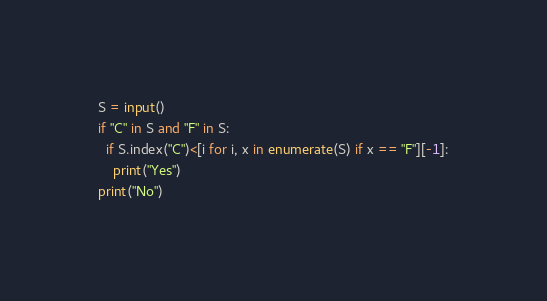<code> <loc_0><loc_0><loc_500><loc_500><_Python_>S = input()
if "C" in S and "F" in S:
  if S.index("C")<[i for i, x in enumerate(S) if x == "F"][-1]:
    print("Yes")
print("No")
</code> 